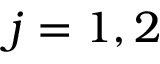<formula> <loc_0><loc_0><loc_500><loc_500>j = 1 , 2</formula> 